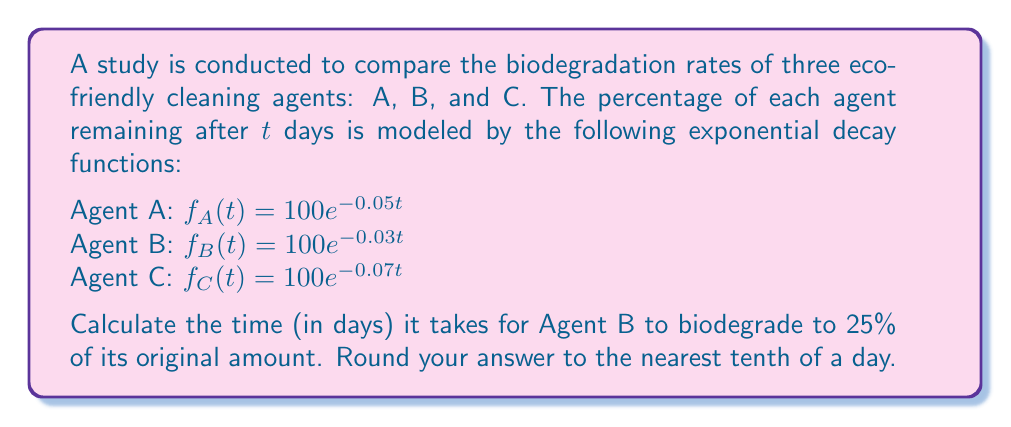Provide a solution to this math problem. To solve this problem, we need to use the exponential decay function for Agent B and determine when it reaches 25% of its original amount. Let's approach this step-by-step:

1. The function for Agent B is given as:
   $f_B(t) = 100e^{-0.03t}$

2. We want to find t when $f_B(t) = 25$, as 25% is equivalent to 25 when the original amount is 100%.

3. Set up the equation:
   $25 = 100e^{-0.03t}$

4. Divide both sides by 100:
   $0.25 = e^{-0.03t}$

5. Take the natural logarithm of both sides:
   $\ln(0.25) = \ln(e^{-0.03t})$

6. Simplify the right side using the properties of logarithms:
   $\ln(0.25) = -0.03t$

7. Solve for t:
   $t = \frac{\ln(0.25)}{-0.03}$

8. Calculate the value:
   $t = \frac{-1.3862943611}{-0.03} \approx 46.2098$

9. Round to the nearest tenth:
   $t \approx 46.2$ days

Therefore, it takes approximately 46.2 days for Agent B to biodegrade to 25% of its original amount.
Answer: 46.2 days 